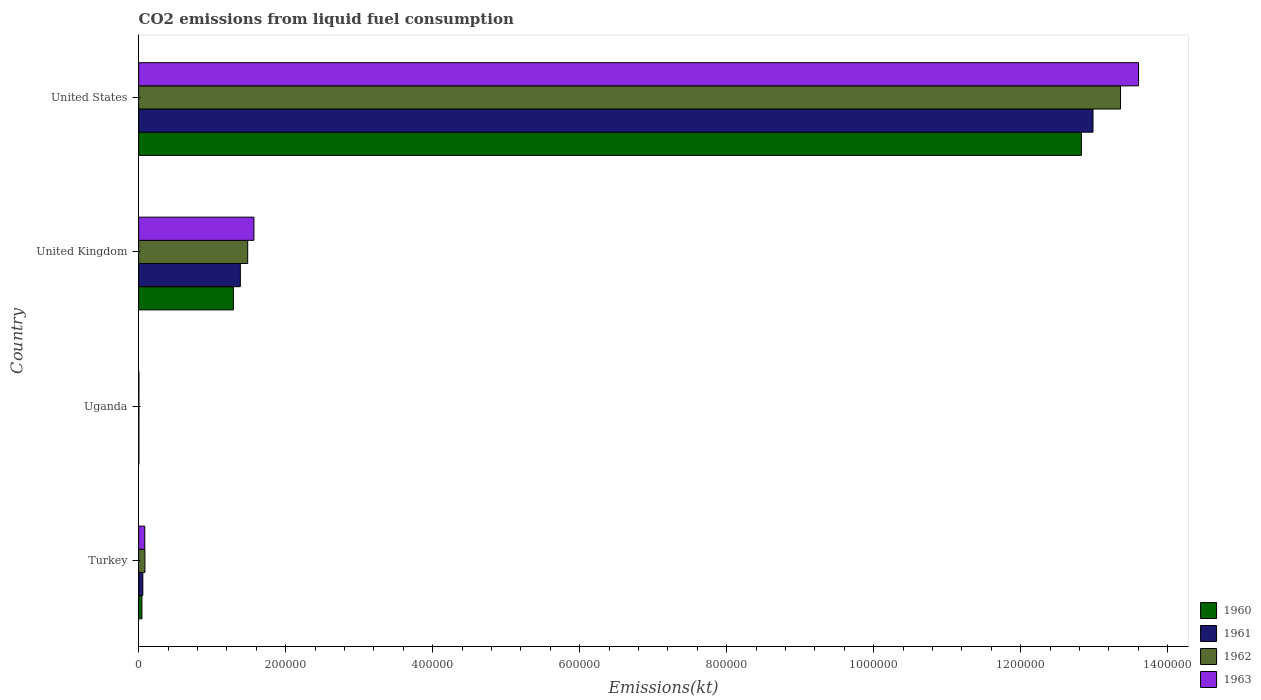How many groups of bars are there?
Make the answer very short. 4. Are the number of bars per tick equal to the number of legend labels?
Offer a terse response. Yes. Are the number of bars on each tick of the Y-axis equal?
Ensure brevity in your answer.  Yes. How many bars are there on the 2nd tick from the top?
Your answer should be compact. 4. How many bars are there on the 4th tick from the bottom?
Give a very brief answer. 4. What is the label of the 2nd group of bars from the top?
Make the answer very short. United Kingdom. What is the amount of CO2 emitted in 1962 in Turkey?
Offer a terse response. 8566.11. Across all countries, what is the maximum amount of CO2 emitted in 1960?
Give a very brief answer. 1.28e+06. Across all countries, what is the minimum amount of CO2 emitted in 1963?
Make the answer very short. 407.04. In which country was the amount of CO2 emitted in 1963 minimum?
Give a very brief answer. Uganda. What is the total amount of CO2 emitted in 1961 in the graph?
Provide a succinct answer. 1.44e+06. What is the difference between the amount of CO2 emitted in 1963 in Turkey and that in Uganda?
Provide a short and direct response. 7946.39. What is the difference between the amount of CO2 emitted in 1963 in United States and the amount of CO2 emitted in 1961 in Uganda?
Keep it short and to the point. 1.36e+06. What is the average amount of CO2 emitted in 1962 per country?
Make the answer very short. 3.73e+05. What is the difference between the amount of CO2 emitted in 1962 and amount of CO2 emitted in 1960 in United States?
Ensure brevity in your answer.  5.32e+04. In how many countries, is the amount of CO2 emitted in 1961 greater than 40000 kt?
Provide a succinct answer. 2. What is the ratio of the amount of CO2 emitted in 1960 in Uganda to that in United Kingdom?
Offer a terse response. 0. Is the difference between the amount of CO2 emitted in 1962 in United Kingdom and United States greater than the difference between the amount of CO2 emitted in 1960 in United Kingdom and United States?
Offer a terse response. No. What is the difference between the highest and the second highest amount of CO2 emitted in 1963?
Provide a short and direct response. 1.20e+06. What is the difference between the highest and the lowest amount of CO2 emitted in 1961?
Offer a very short reply. 1.30e+06. In how many countries, is the amount of CO2 emitted in 1962 greater than the average amount of CO2 emitted in 1962 taken over all countries?
Offer a very short reply. 1. Is the sum of the amount of CO2 emitted in 1962 in Turkey and United Kingdom greater than the maximum amount of CO2 emitted in 1963 across all countries?
Ensure brevity in your answer.  No. How many bars are there?
Provide a succinct answer. 16. Are all the bars in the graph horizontal?
Give a very brief answer. Yes. How many countries are there in the graph?
Your response must be concise. 4. What is the difference between two consecutive major ticks on the X-axis?
Offer a very short reply. 2.00e+05. Where does the legend appear in the graph?
Provide a short and direct response. Bottom right. How many legend labels are there?
Your answer should be compact. 4. What is the title of the graph?
Ensure brevity in your answer.  CO2 emissions from liquid fuel consumption. Does "2010" appear as one of the legend labels in the graph?
Give a very brief answer. No. What is the label or title of the X-axis?
Offer a terse response. Emissions(kt). What is the label or title of the Y-axis?
Provide a succinct answer. Country. What is the Emissions(kt) of 1960 in Turkey?
Offer a very short reply. 4473.74. What is the Emissions(kt) of 1961 in Turkey?
Your answer should be very brief. 5720.52. What is the Emissions(kt) of 1962 in Turkey?
Provide a succinct answer. 8566.11. What is the Emissions(kt) of 1963 in Turkey?
Your answer should be compact. 8353.43. What is the Emissions(kt) in 1960 in Uganda?
Give a very brief answer. 385.04. What is the Emissions(kt) in 1961 in Uganda?
Ensure brevity in your answer.  374.03. What is the Emissions(kt) in 1962 in Uganda?
Provide a succinct answer. 399.7. What is the Emissions(kt) in 1963 in Uganda?
Give a very brief answer. 407.04. What is the Emissions(kt) of 1960 in United Kingdom?
Your answer should be very brief. 1.29e+05. What is the Emissions(kt) of 1961 in United Kingdom?
Provide a short and direct response. 1.38e+05. What is the Emissions(kt) of 1962 in United Kingdom?
Make the answer very short. 1.48e+05. What is the Emissions(kt) in 1963 in United Kingdom?
Offer a terse response. 1.57e+05. What is the Emissions(kt) in 1960 in United States?
Provide a short and direct response. 1.28e+06. What is the Emissions(kt) in 1961 in United States?
Offer a very short reply. 1.30e+06. What is the Emissions(kt) in 1962 in United States?
Make the answer very short. 1.34e+06. What is the Emissions(kt) of 1963 in United States?
Your response must be concise. 1.36e+06. Across all countries, what is the maximum Emissions(kt) of 1960?
Ensure brevity in your answer.  1.28e+06. Across all countries, what is the maximum Emissions(kt) in 1961?
Offer a terse response. 1.30e+06. Across all countries, what is the maximum Emissions(kt) of 1962?
Keep it short and to the point. 1.34e+06. Across all countries, what is the maximum Emissions(kt) in 1963?
Provide a succinct answer. 1.36e+06. Across all countries, what is the minimum Emissions(kt) in 1960?
Your response must be concise. 385.04. Across all countries, what is the minimum Emissions(kt) in 1961?
Give a very brief answer. 374.03. Across all countries, what is the minimum Emissions(kt) of 1962?
Ensure brevity in your answer.  399.7. Across all countries, what is the minimum Emissions(kt) of 1963?
Your answer should be very brief. 407.04. What is the total Emissions(kt) of 1960 in the graph?
Make the answer very short. 1.42e+06. What is the total Emissions(kt) of 1961 in the graph?
Offer a terse response. 1.44e+06. What is the total Emissions(kt) in 1962 in the graph?
Your answer should be very brief. 1.49e+06. What is the total Emissions(kt) in 1963 in the graph?
Give a very brief answer. 1.53e+06. What is the difference between the Emissions(kt) in 1960 in Turkey and that in Uganda?
Your response must be concise. 4088.7. What is the difference between the Emissions(kt) in 1961 in Turkey and that in Uganda?
Offer a very short reply. 5346.49. What is the difference between the Emissions(kt) of 1962 in Turkey and that in Uganda?
Give a very brief answer. 8166.41. What is the difference between the Emissions(kt) of 1963 in Turkey and that in Uganda?
Offer a terse response. 7946.39. What is the difference between the Emissions(kt) in 1960 in Turkey and that in United Kingdom?
Your answer should be very brief. -1.25e+05. What is the difference between the Emissions(kt) in 1961 in Turkey and that in United Kingdom?
Offer a very short reply. -1.33e+05. What is the difference between the Emissions(kt) in 1962 in Turkey and that in United Kingdom?
Provide a short and direct response. -1.40e+05. What is the difference between the Emissions(kt) of 1963 in Turkey and that in United Kingdom?
Your answer should be compact. -1.49e+05. What is the difference between the Emissions(kt) of 1960 in Turkey and that in United States?
Your answer should be compact. -1.28e+06. What is the difference between the Emissions(kt) of 1961 in Turkey and that in United States?
Your answer should be very brief. -1.29e+06. What is the difference between the Emissions(kt) of 1962 in Turkey and that in United States?
Give a very brief answer. -1.33e+06. What is the difference between the Emissions(kt) in 1963 in Turkey and that in United States?
Give a very brief answer. -1.35e+06. What is the difference between the Emissions(kt) of 1960 in Uganda and that in United Kingdom?
Ensure brevity in your answer.  -1.29e+05. What is the difference between the Emissions(kt) of 1961 in Uganda and that in United Kingdom?
Provide a succinct answer. -1.38e+05. What is the difference between the Emissions(kt) of 1962 in Uganda and that in United Kingdom?
Ensure brevity in your answer.  -1.48e+05. What is the difference between the Emissions(kt) in 1963 in Uganda and that in United Kingdom?
Ensure brevity in your answer.  -1.56e+05. What is the difference between the Emissions(kt) in 1960 in Uganda and that in United States?
Ensure brevity in your answer.  -1.28e+06. What is the difference between the Emissions(kt) of 1961 in Uganda and that in United States?
Your response must be concise. -1.30e+06. What is the difference between the Emissions(kt) of 1962 in Uganda and that in United States?
Offer a very short reply. -1.34e+06. What is the difference between the Emissions(kt) in 1963 in Uganda and that in United States?
Make the answer very short. -1.36e+06. What is the difference between the Emissions(kt) in 1960 in United Kingdom and that in United States?
Your response must be concise. -1.15e+06. What is the difference between the Emissions(kt) in 1961 in United Kingdom and that in United States?
Your answer should be compact. -1.16e+06. What is the difference between the Emissions(kt) of 1962 in United Kingdom and that in United States?
Give a very brief answer. -1.19e+06. What is the difference between the Emissions(kt) in 1963 in United Kingdom and that in United States?
Ensure brevity in your answer.  -1.20e+06. What is the difference between the Emissions(kt) in 1960 in Turkey and the Emissions(kt) in 1961 in Uganda?
Provide a succinct answer. 4099.71. What is the difference between the Emissions(kt) of 1960 in Turkey and the Emissions(kt) of 1962 in Uganda?
Ensure brevity in your answer.  4074.04. What is the difference between the Emissions(kt) in 1960 in Turkey and the Emissions(kt) in 1963 in Uganda?
Make the answer very short. 4066.7. What is the difference between the Emissions(kt) in 1961 in Turkey and the Emissions(kt) in 1962 in Uganda?
Provide a succinct answer. 5320.82. What is the difference between the Emissions(kt) in 1961 in Turkey and the Emissions(kt) in 1963 in Uganda?
Ensure brevity in your answer.  5313.48. What is the difference between the Emissions(kt) of 1962 in Turkey and the Emissions(kt) of 1963 in Uganda?
Make the answer very short. 8159.07. What is the difference between the Emissions(kt) of 1960 in Turkey and the Emissions(kt) of 1961 in United Kingdom?
Make the answer very short. -1.34e+05. What is the difference between the Emissions(kt) in 1960 in Turkey and the Emissions(kt) in 1962 in United Kingdom?
Provide a succinct answer. -1.44e+05. What is the difference between the Emissions(kt) in 1960 in Turkey and the Emissions(kt) in 1963 in United Kingdom?
Give a very brief answer. -1.52e+05. What is the difference between the Emissions(kt) in 1961 in Turkey and the Emissions(kt) in 1962 in United Kingdom?
Provide a short and direct response. -1.43e+05. What is the difference between the Emissions(kt) of 1961 in Turkey and the Emissions(kt) of 1963 in United Kingdom?
Give a very brief answer. -1.51e+05. What is the difference between the Emissions(kt) of 1962 in Turkey and the Emissions(kt) of 1963 in United Kingdom?
Provide a succinct answer. -1.48e+05. What is the difference between the Emissions(kt) of 1960 in Turkey and the Emissions(kt) of 1961 in United States?
Provide a succinct answer. -1.29e+06. What is the difference between the Emissions(kt) in 1960 in Turkey and the Emissions(kt) in 1962 in United States?
Give a very brief answer. -1.33e+06. What is the difference between the Emissions(kt) in 1960 in Turkey and the Emissions(kt) in 1963 in United States?
Provide a succinct answer. -1.36e+06. What is the difference between the Emissions(kt) in 1961 in Turkey and the Emissions(kt) in 1962 in United States?
Your answer should be very brief. -1.33e+06. What is the difference between the Emissions(kt) of 1961 in Turkey and the Emissions(kt) of 1963 in United States?
Provide a succinct answer. -1.35e+06. What is the difference between the Emissions(kt) in 1962 in Turkey and the Emissions(kt) in 1963 in United States?
Give a very brief answer. -1.35e+06. What is the difference between the Emissions(kt) in 1960 in Uganda and the Emissions(kt) in 1961 in United Kingdom?
Your response must be concise. -1.38e+05. What is the difference between the Emissions(kt) of 1960 in Uganda and the Emissions(kt) of 1962 in United Kingdom?
Provide a succinct answer. -1.48e+05. What is the difference between the Emissions(kt) in 1960 in Uganda and the Emissions(kt) in 1963 in United Kingdom?
Give a very brief answer. -1.56e+05. What is the difference between the Emissions(kt) in 1961 in Uganda and the Emissions(kt) in 1962 in United Kingdom?
Make the answer very short. -1.48e+05. What is the difference between the Emissions(kt) in 1961 in Uganda and the Emissions(kt) in 1963 in United Kingdom?
Your answer should be very brief. -1.56e+05. What is the difference between the Emissions(kt) of 1962 in Uganda and the Emissions(kt) of 1963 in United Kingdom?
Make the answer very short. -1.56e+05. What is the difference between the Emissions(kt) in 1960 in Uganda and the Emissions(kt) in 1961 in United States?
Provide a short and direct response. -1.30e+06. What is the difference between the Emissions(kt) in 1960 in Uganda and the Emissions(kt) in 1962 in United States?
Give a very brief answer. -1.34e+06. What is the difference between the Emissions(kt) of 1960 in Uganda and the Emissions(kt) of 1963 in United States?
Give a very brief answer. -1.36e+06. What is the difference between the Emissions(kt) of 1961 in Uganda and the Emissions(kt) of 1962 in United States?
Your answer should be very brief. -1.34e+06. What is the difference between the Emissions(kt) in 1961 in Uganda and the Emissions(kt) in 1963 in United States?
Offer a very short reply. -1.36e+06. What is the difference between the Emissions(kt) in 1962 in Uganda and the Emissions(kt) in 1963 in United States?
Your answer should be compact. -1.36e+06. What is the difference between the Emissions(kt) in 1960 in United Kingdom and the Emissions(kt) in 1961 in United States?
Offer a very short reply. -1.17e+06. What is the difference between the Emissions(kt) in 1960 in United Kingdom and the Emissions(kt) in 1962 in United States?
Ensure brevity in your answer.  -1.21e+06. What is the difference between the Emissions(kt) of 1960 in United Kingdom and the Emissions(kt) of 1963 in United States?
Keep it short and to the point. -1.23e+06. What is the difference between the Emissions(kt) in 1961 in United Kingdom and the Emissions(kt) in 1962 in United States?
Your answer should be very brief. -1.20e+06. What is the difference between the Emissions(kt) in 1961 in United Kingdom and the Emissions(kt) in 1963 in United States?
Provide a succinct answer. -1.22e+06. What is the difference between the Emissions(kt) of 1962 in United Kingdom and the Emissions(kt) of 1963 in United States?
Offer a very short reply. -1.21e+06. What is the average Emissions(kt) of 1960 per country?
Offer a terse response. 3.54e+05. What is the average Emissions(kt) in 1961 per country?
Make the answer very short. 3.61e+05. What is the average Emissions(kt) in 1962 per country?
Give a very brief answer. 3.73e+05. What is the average Emissions(kt) in 1963 per country?
Provide a succinct answer. 3.81e+05. What is the difference between the Emissions(kt) of 1960 and Emissions(kt) of 1961 in Turkey?
Keep it short and to the point. -1246.78. What is the difference between the Emissions(kt) of 1960 and Emissions(kt) of 1962 in Turkey?
Your response must be concise. -4092.37. What is the difference between the Emissions(kt) in 1960 and Emissions(kt) in 1963 in Turkey?
Give a very brief answer. -3879.69. What is the difference between the Emissions(kt) of 1961 and Emissions(kt) of 1962 in Turkey?
Provide a short and direct response. -2845.59. What is the difference between the Emissions(kt) in 1961 and Emissions(kt) in 1963 in Turkey?
Offer a terse response. -2632.91. What is the difference between the Emissions(kt) in 1962 and Emissions(kt) in 1963 in Turkey?
Ensure brevity in your answer.  212.69. What is the difference between the Emissions(kt) of 1960 and Emissions(kt) of 1961 in Uganda?
Offer a terse response. 11. What is the difference between the Emissions(kt) of 1960 and Emissions(kt) of 1962 in Uganda?
Provide a succinct answer. -14.67. What is the difference between the Emissions(kt) of 1960 and Emissions(kt) of 1963 in Uganda?
Your response must be concise. -22. What is the difference between the Emissions(kt) in 1961 and Emissions(kt) in 1962 in Uganda?
Ensure brevity in your answer.  -25.67. What is the difference between the Emissions(kt) in 1961 and Emissions(kt) in 1963 in Uganda?
Your response must be concise. -33. What is the difference between the Emissions(kt) in 1962 and Emissions(kt) in 1963 in Uganda?
Your response must be concise. -7.33. What is the difference between the Emissions(kt) of 1960 and Emissions(kt) of 1961 in United Kingdom?
Ensure brevity in your answer.  -9380.19. What is the difference between the Emissions(kt) of 1960 and Emissions(kt) of 1962 in United Kingdom?
Provide a succinct answer. -1.94e+04. What is the difference between the Emissions(kt) in 1960 and Emissions(kt) in 1963 in United Kingdom?
Ensure brevity in your answer.  -2.79e+04. What is the difference between the Emissions(kt) of 1961 and Emissions(kt) of 1962 in United Kingdom?
Your answer should be compact. -9992.58. What is the difference between the Emissions(kt) in 1961 and Emissions(kt) in 1963 in United Kingdom?
Your answer should be very brief. -1.85e+04. What is the difference between the Emissions(kt) in 1962 and Emissions(kt) in 1963 in United Kingdom?
Ensure brevity in your answer.  -8489.1. What is the difference between the Emissions(kt) of 1960 and Emissions(kt) of 1961 in United States?
Your answer should be very brief. -1.57e+04. What is the difference between the Emissions(kt) of 1960 and Emissions(kt) of 1962 in United States?
Offer a terse response. -5.32e+04. What is the difference between the Emissions(kt) in 1960 and Emissions(kt) in 1963 in United States?
Keep it short and to the point. -7.77e+04. What is the difference between the Emissions(kt) of 1961 and Emissions(kt) of 1962 in United States?
Provide a short and direct response. -3.75e+04. What is the difference between the Emissions(kt) in 1961 and Emissions(kt) in 1963 in United States?
Provide a succinct answer. -6.20e+04. What is the difference between the Emissions(kt) in 1962 and Emissions(kt) in 1963 in United States?
Give a very brief answer. -2.45e+04. What is the ratio of the Emissions(kt) of 1960 in Turkey to that in Uganda?
Provide a short and direct response. 11.62. What is the ratio of the Emissions(kt) in 1961 in Turkey to that in Uganda?
Make the answer very short. 15.29. What is the ratio of the Emissions(kt) in 1962 in Turkey to that in Uganda?
Keep it short and to the point. 21.43. What is the ratio of the Emissions(kt) of 1963 in Turkey to that in Uganda?
Your answer should be compact. 20.52. What is the ratio of the Emissions(kt) of 1960 in Turkey to that in United Kingdom?
Your response must be concise. 0.03. What is the ratio of the Emissions(kt) in 1961 in Turkey to that in United Kingdom?
Keep it short and to the point. 0.04. What is the ratio of the Emissions(kt) of 1962 in Turkey to that in United Kingdom?
Your answer should be compact. 0.06. What is the ratio of the Emissions(kt) in 1963 in Turkey to that in United Kingdom?
Ensure brevity in your answer.  0.05. What is the ratio of the Emissions(kt) of 1960 in Turkey to that in United States?
Give a very brief answer. 0. What is the ratio of the Emissions(kt) of 1961 in Turkey to that in United States?
Your answer should be very brief. 0. What is the ratio of the Emissions(kt) of 1962 in Turkey to that in United States?
Provide a succinct answer. 0.01. What is the ratio of the Emissions(kt) of 1963 in Turkey to that in United States?
Your answer should be compact. 0.01. What is the ratio of the Emissions(kt) of 1960 in Uganda to that in United Kingdom?
Your answer should be very brief. 0. What is the ratio of the Emissions(kt) in 1961 in Uganda to that in United Kingdom?
Provide a succinct answer. 0. What is the ratio of the Emissions(kt) of 1962 in Uganda to that in United Kingdom?
Keep it short and to the point. 0. What is the ratio of the Emissions(kt) of 1963 in Uganda to that in United Kingdom?
Your response must be concise. 0. What is the ratio of the Emissions(kt) in 1961 in Uganda to that in United States?
Make the answer very short. 0. What is the ratio of the Emissions(kt) of 1963 in Uganda to that in United States?
Keep it short and to the point. 0. What is the ratio of the Emissions(kt) of 1960 in United Kingdom to that in United States?
Your response must be concise. 0.1. What is the ratio of the Emissions(kt) of 1961 in United Kingdom to that in United States?
Offer a terse response. 0.11. What is the ratio of the Emissions(kt) of 1963 in United Kingdom to that in United States?
Ensure brevity in your answer.  0.12. What is the difference between the highest and the second highest Emissions(kt) in 1960?
Make the answer very short. 1.15e+06. What is the difference between the highest and the second highest Emissions(kt) of 1961?
Your answer should be very brief. 1.16e+06. What is the difference between the highest and the second highest Emissions(kt) in 1962?
Provide a short and direct response. 1.19e+06. What is the difference between the highest and the second highest Emissions(kt) of 1963?
Your answer should be compact. 1.20e+06. What is the difference between the highest and the lowest Emissions(kt) in 1960?
Offer a very short reply. 1.28e+06. What is the difference between the highest and the lowest Emissions(kt) of 1961?
Your answer should be compact. 1.30e+06. What is the difference between the highest and the lowest Emissions(kt) of 1962?
Give a very brief answer. 1.34e+06. What is the difference between the highest and the lowest Emissions(kt) of 1963?
Provide a succinct answer. 1.36e+06. 